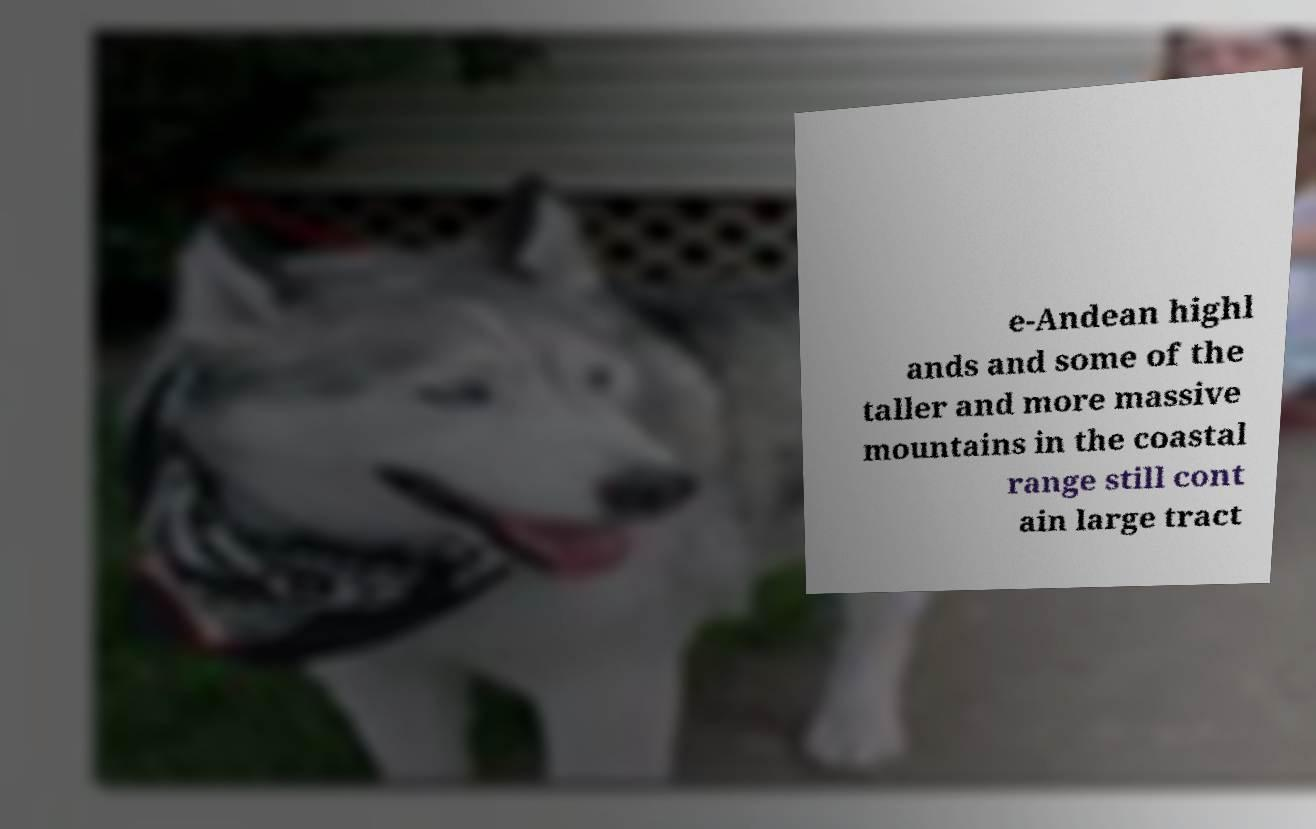Please read and relay the text visible in this image. What does it say? e-Andean highl ands and some of the taller and more massive mountains in the coastal range still cont ain large tract 